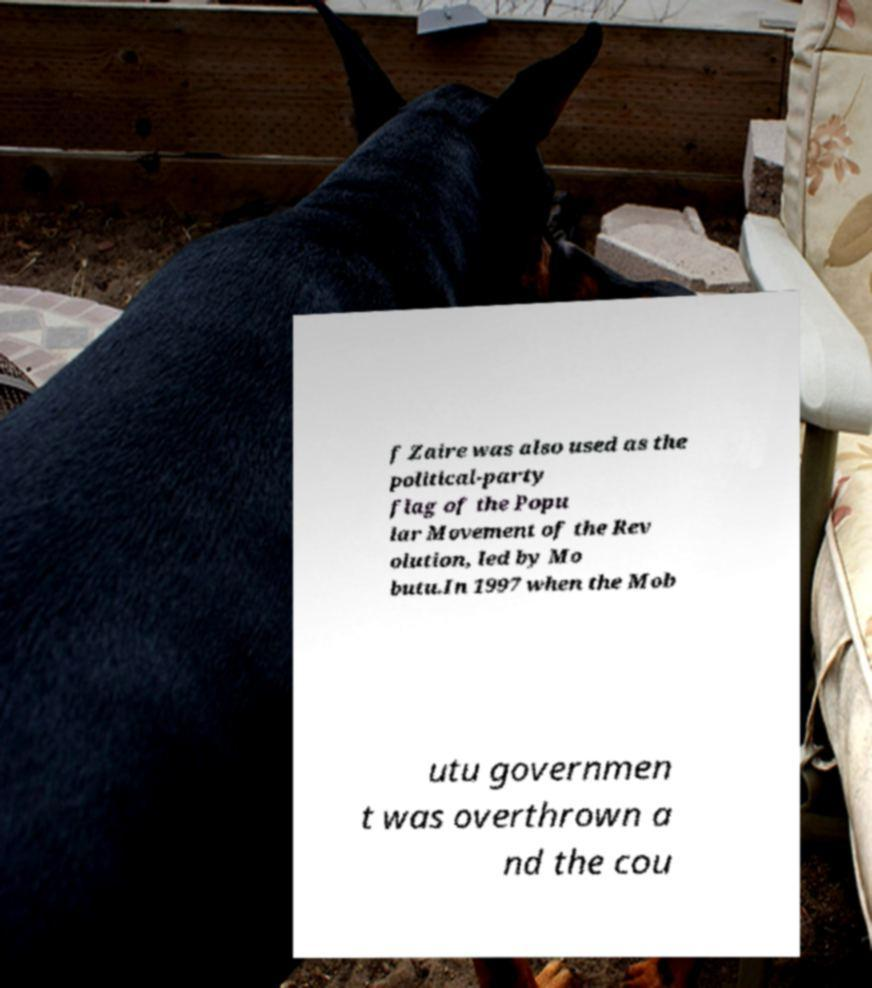Could you assist in decoding the text presented in this image and type it out clearly? f Zaire was also used as the political-party flag of the Popu lar Movement of the Rev olution, led by Mo butu.In 1997 when the Mob utu governmen t was overthrown a nd the cou 